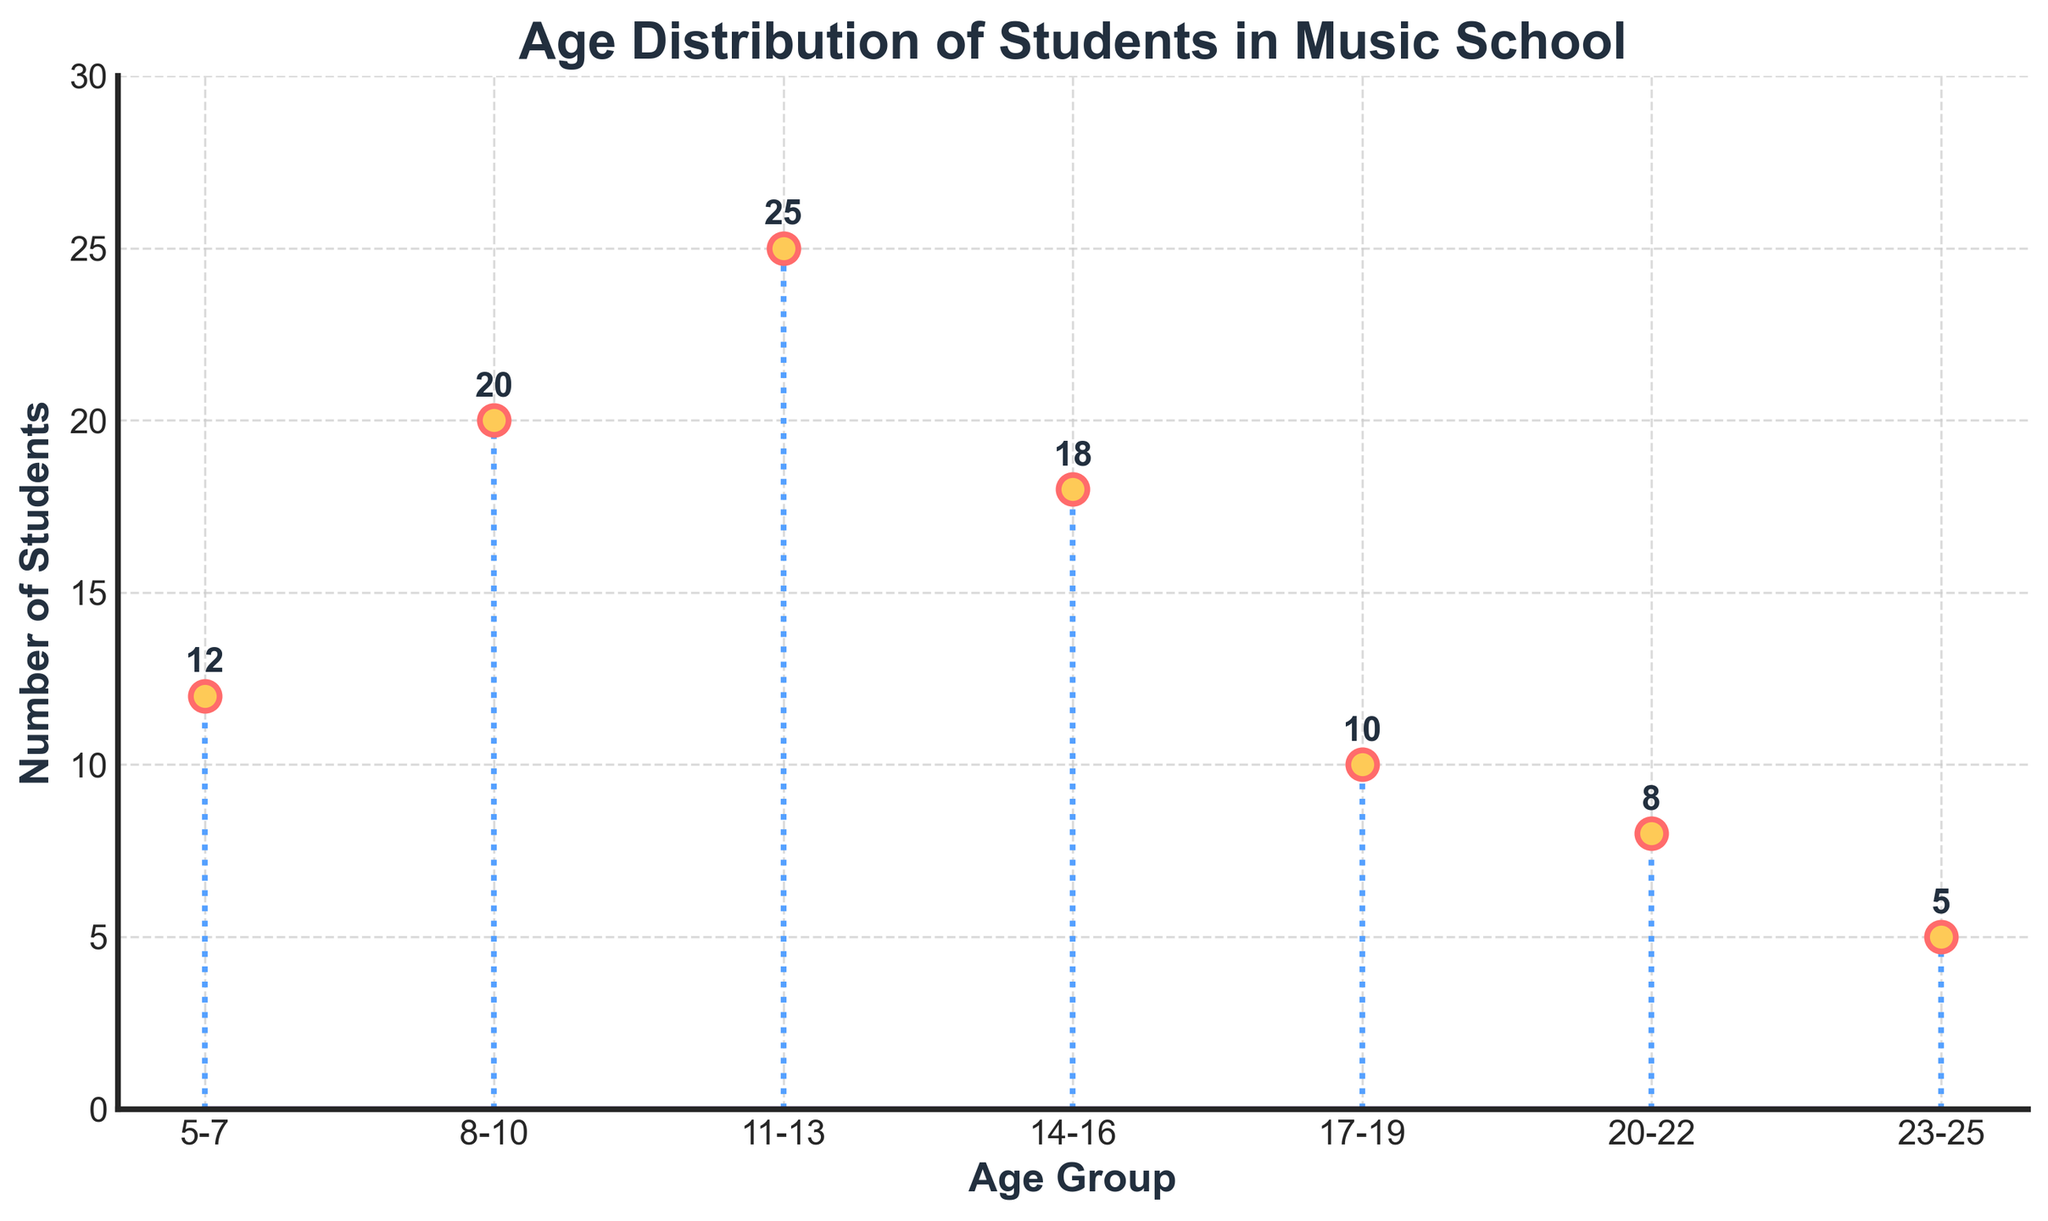How many age groups are displayed in the plot? To find the number of age groups, count the distinct categories along the x-axis. There are 7 age groups shown in the plot: 5-7, 8-10, 11-13, 14-16, 17-19, 20-22, and 23-25.
Answer: 7 Which age group has the highest number of students? Look for the age group that has the highest point on the y-axis. The 11-13 age group has 25 students, which is the highest value visible in the plot.
Answer: 11-13 What is the total number of students enrolled in the music school? Add the number of students in each age group: 12 (5-7) + 20 (8-10) + 25 (11-13) + 18 (14-16) + 10 (17-19) + 8 (20-22) + 5 (23-25) = 98.
Answer: 98 How many more students are there in the 11-13 age group compared to the 17-19 age group? Calculate the difference between students in the 11-13 and 17-19 age groups: 25 (11-13) - 10 (17-19) = 15.
Answer: 15 Which age groups have fewer than 10 students? Identify the age groups with data points below 10 on the y-axis: 20-22 and 23-25 age groups have 8 and 5 students respectively.
Answer: 20-22, 23-25 What is the average number of students across all age groups? The total number of students is 98, and there are 7 age groups. Average is calculated as 98 divided by 7: 98 / 7 = 14 students per age group on average.
Answer: 14 Which age group has the second highest number of students? Find the age group with the second highest point on the y-axis. The 8-10 age group has the second highest value at 20 students, after the 11-13 age group.
Answer: 8-10 Do more students belong to the first three age groups (5-7, 8-10, 11-13) or the last three age groups (17-19, 20-22, 23-25)? Sum the students in the first three age groups and compare to the sum of the last three: first three (12 + 20 + 25 = 57), last three (10 + 8 + 5 = 23). 57 is greater than 23.
Answer: First three What is the difference in the number of students between the 14-16 and 5-7 age groups? Subtract the number of students in the 5-7 age group from the 14-16 age group: 18 (14-16) - 12 (5-7) = 6.
Answer: 6 